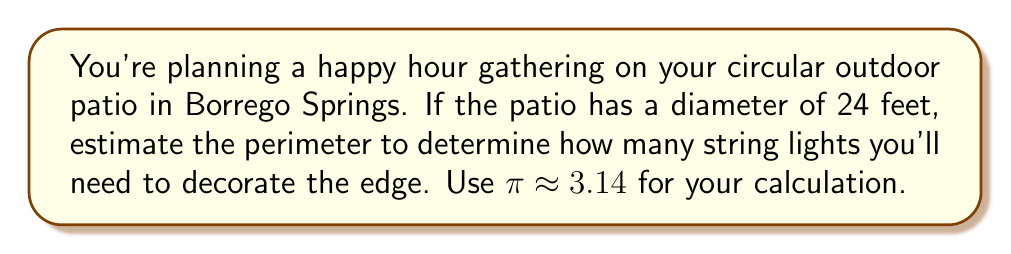Give your solution to this math problem. Let's approach this step-by-step:

1) The formula for the circumference (perimeter) of a circle is:
   $$C = \pi d$$
   where $C$ is the circumference, $\pi$ is pi, and $d$ is the diameter.

2) We're given that the diameter is 24 feet and we should use $\pi \approx 3.14$.

3) Let's substitute these values into our formula:
   $$C \approx 3.14 \times 24$$

4) Now, let's calculate:
   $$C \approx 75.36\text{ feet}$$

5) Since we're estimating for string lights, it's reasonable to round to the nearest foot:
   $$C \approx 75\text{ feet}$$

[asy]
unitsize(0.1inch);
draw(circle((0,0),12), rgb(0,0,1));
draw((-12,0)--(12,0), rgb(1,0,0));
label("24 ft", (0,-13), rgb(1,0,0));
label("≈ 75 ft", (17,0), rgb(0,0,1));
[/asy]

Therefore, you'll need approximately 75 feet of string lights to decorate the edge of your circular patio for your happy hour gathering.
Answer: $75\text{ feet}$ 